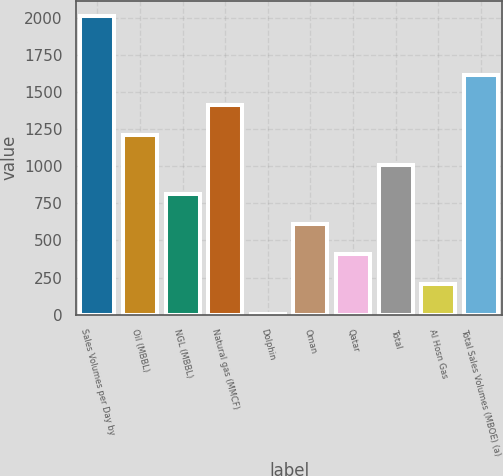<chart> <loc_0><loc_0><loc_500><loc_500><bar_chart><fcel>Sales Volumes per Day by<fcel>Oil (MBBL)<fcel>NGL (MBBL)<fcel>Natural gas (MMCF)<fcel>Dolphin<fcel>Oman<fcel>Qatar<fcel>Total<fcel>Al Hosn Gas<fcel>Total Sales Volumes (MBOE) (a)<nl><fcel>2018<fcel>1213.6<fcel>811.4<fcel>1414.7<fcel>7<fcel>610.3<fcel>409.2<fcel>1012.5<fcel>208.1<fcel>1615.8<nl></chart> 